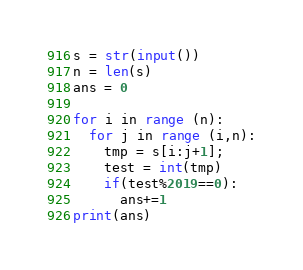<code> <loc_0><loc_0><loc_500><loc_500><_Python_>s = str(input())
n = len(s)
ans = 0

for i in range (n):
  for j in range (i,n):
    tmp = s[i:j+1];
    test = int(tmp)
    if(test%2019==0):
      ans+=1
print(ans)</code> 